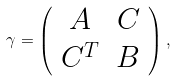<formula> <loc_0><loc_0><loc_500><loc_500>\gamma = \left ( \begin{array} { c c } A & C \\ C ^ { T } & B \end{array} \right ) ,</formula> 